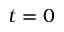Convert formula to latex. <formula><loc_0><loc_0><loc_500><loc_500>t = 0</formula> 